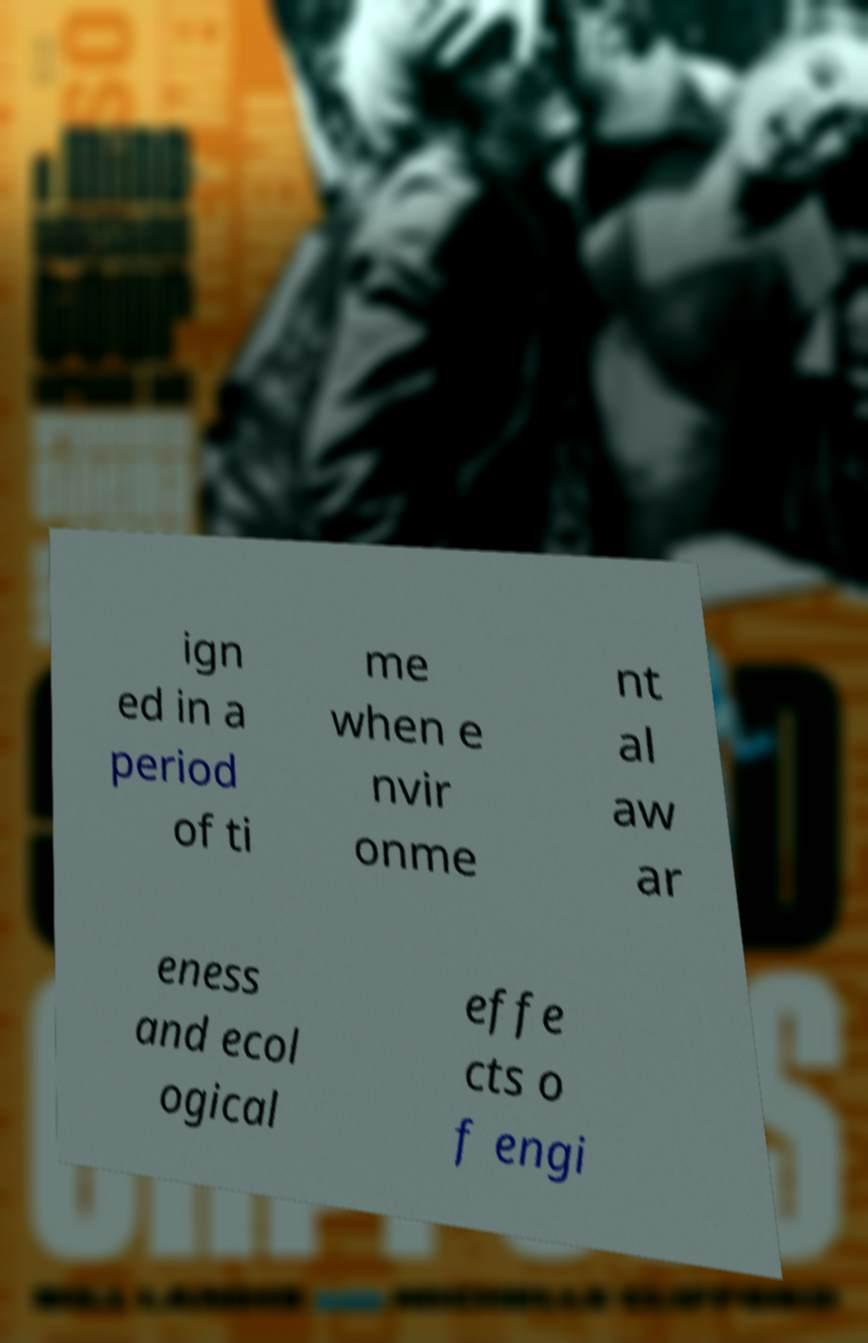For documentation purposes, I need the text within this image transcribed. Could you provide that? ign ed in a period of ti me when e nvir onme nt al aw ar eness and ecol ogical effe cts o f engi 